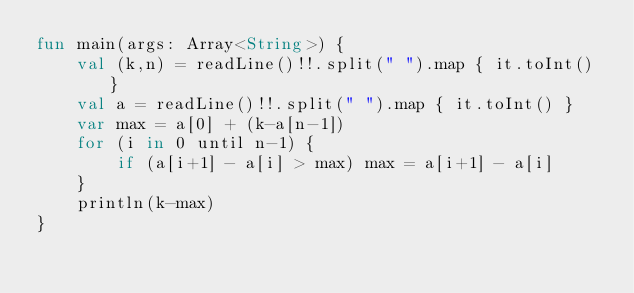<code> <loc_0><loc_0><loc_500><loc_500><_Kotlin_>fun main(args: Array<String>) {
    val (k,n) = readLine()!!.split(" ").map { it.toInt() }
    val a = readLine()!!.split(" ").map { it.toInt() }
    var max = a[0] + (k-a[n-1])
    for (i in 0 until n-1) {
        if (a[i+1] - a[i] > max) max = a[i+1] - a[i]
    }
    println(k-max)
}
</code> 